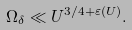<formula> <loc_0><loc_0><loc_500><loc_500>\Omega _ { \delta } \ll U ^ { 3 / 4 + \varepsilon ( U ) } .</formula> 